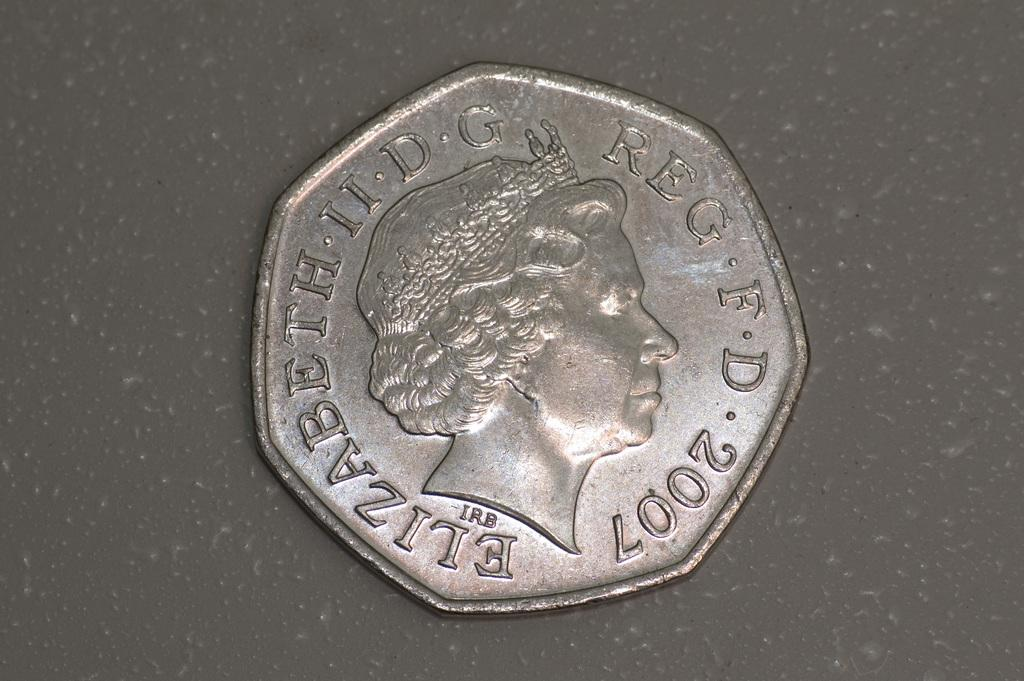<image>
Offer a succinct explanation of the picture presented. an octagon shaped coin reading Elizabeth II DG 2007 